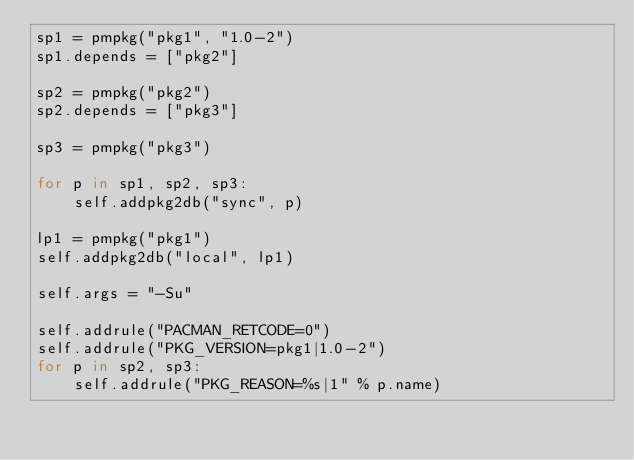<code> <loc_0><loc_0><loc_500><loc_500><_Python_>sp1 = pmpkg("pkg1", "1.0-2")
sp1.depends = ["pkg2"]

sp2 = pmpkg("pkg2")
sp2.depends = ["pkg3"]

sp3 = pmpkg("pkg3")

for p in sp1, sp2, sp3:
	self.addpkg2db("sync", p)

lp1 = pmpkg("pkg1")
self.addpkg2db("local", lp1)

self.args = "-Su"

self.addrule("PACMAN_RETCODE=0")
self.addrule("PKG_VERSION=pkg1|1.0-2")
for p in sp2, sp3:
	self.addrule("PKG_REASON=%s|1" % p.name)
</code> 